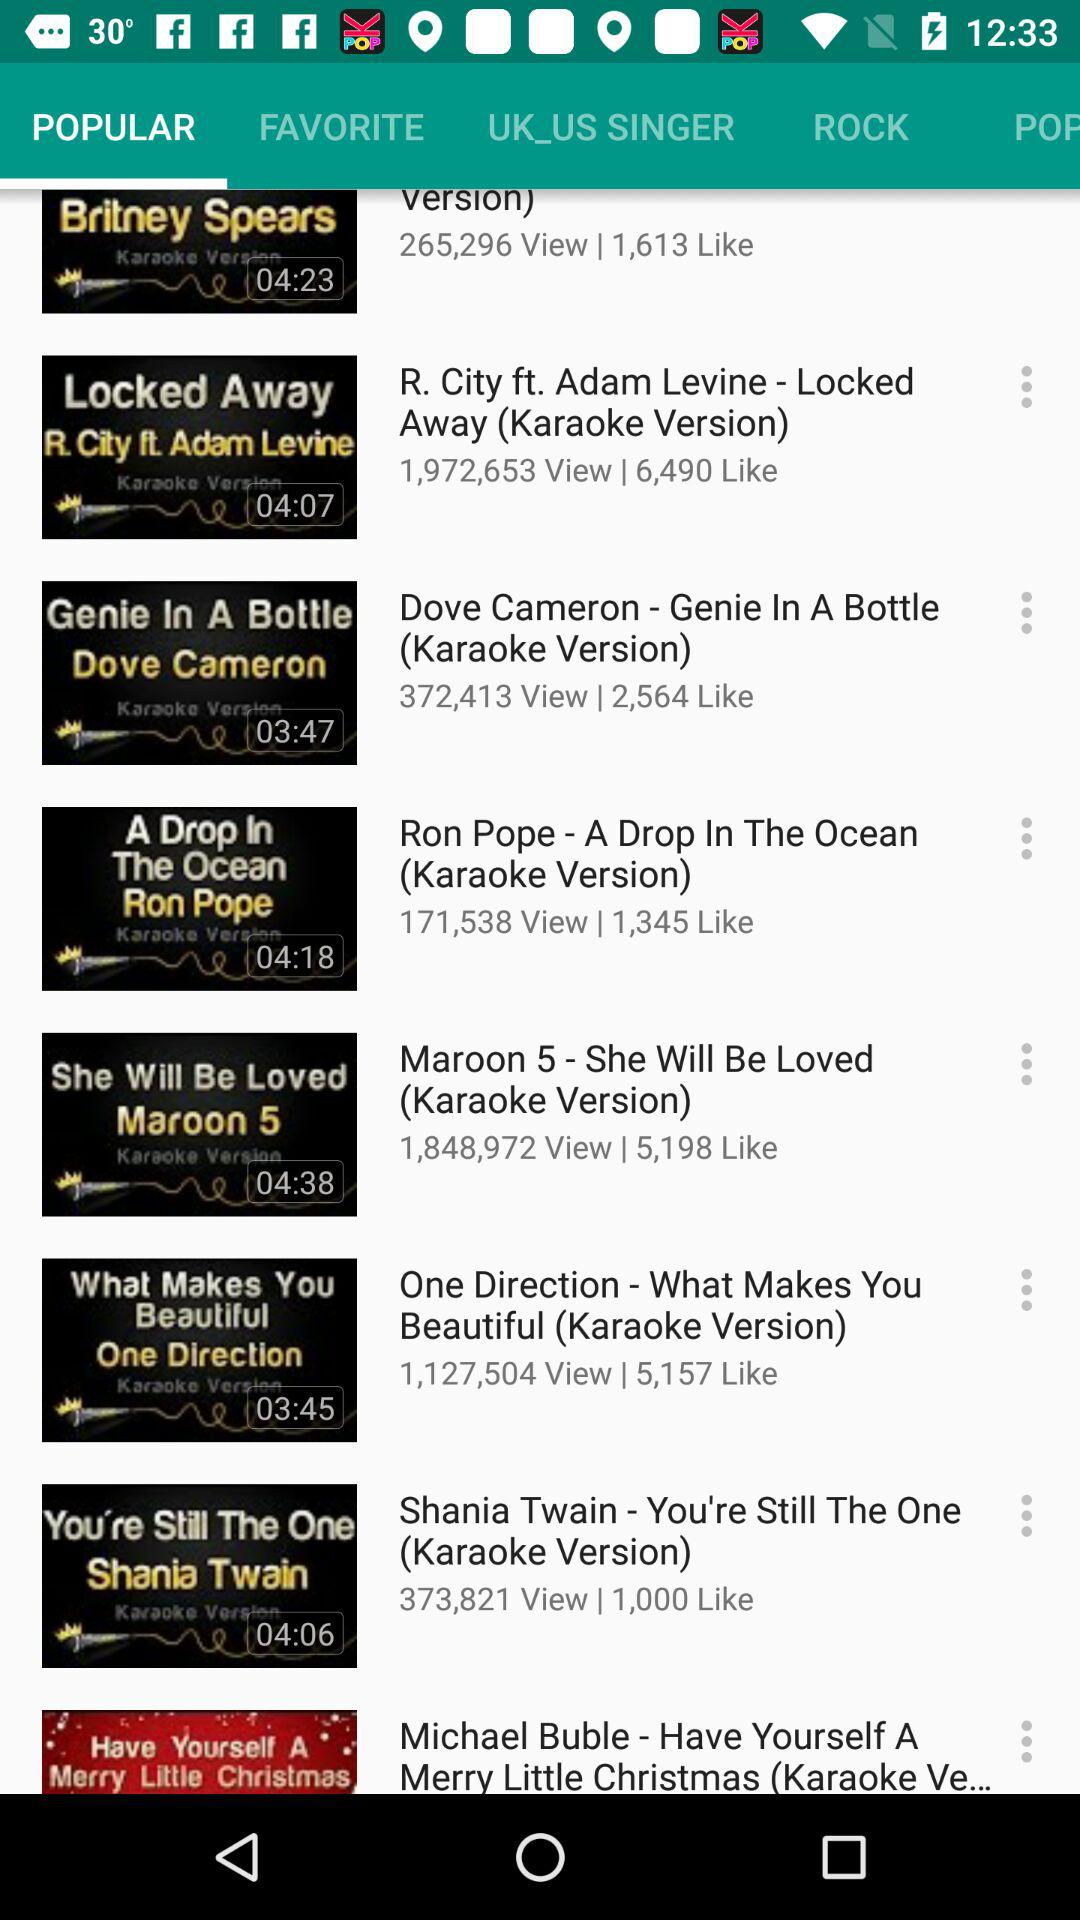What is viewer time?
When the provided information is insufficient, respond with <no answer>. <no answer> 